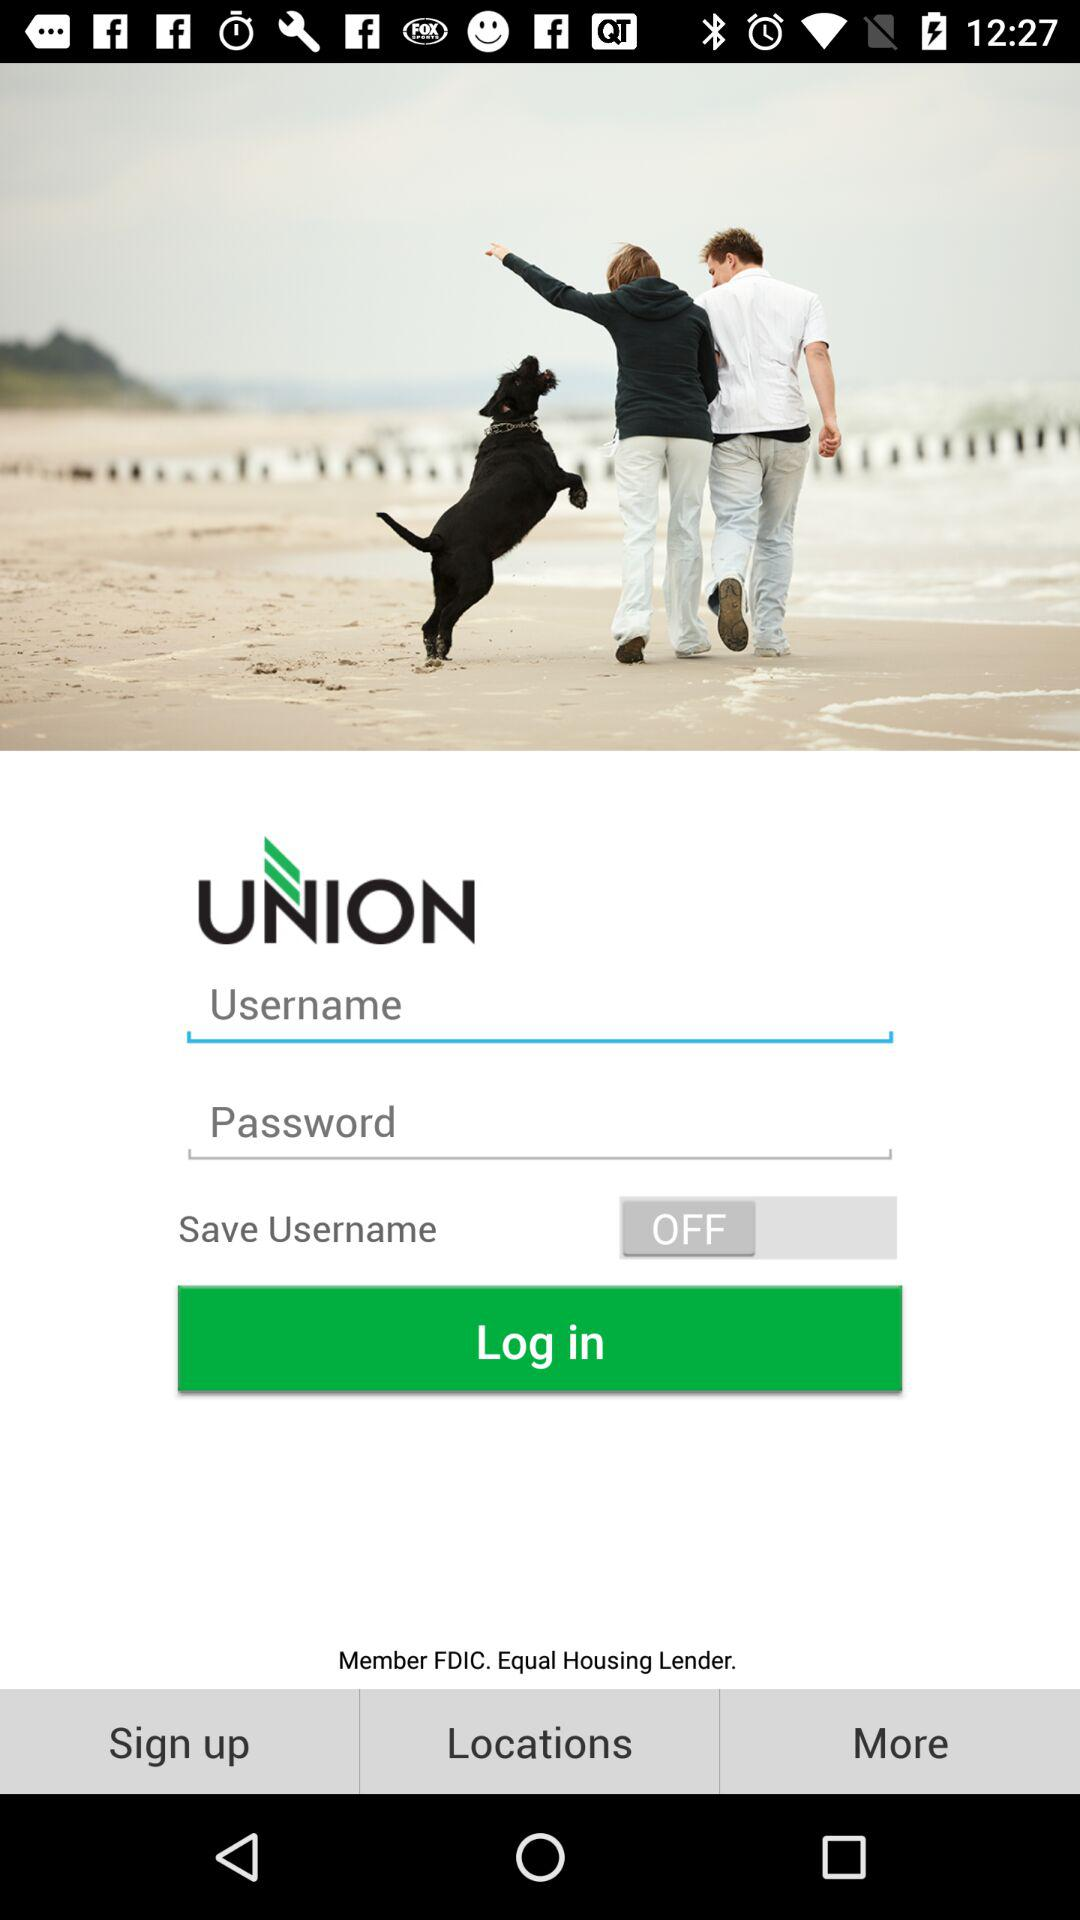What is the status of "Save Username"? The status is "off". 